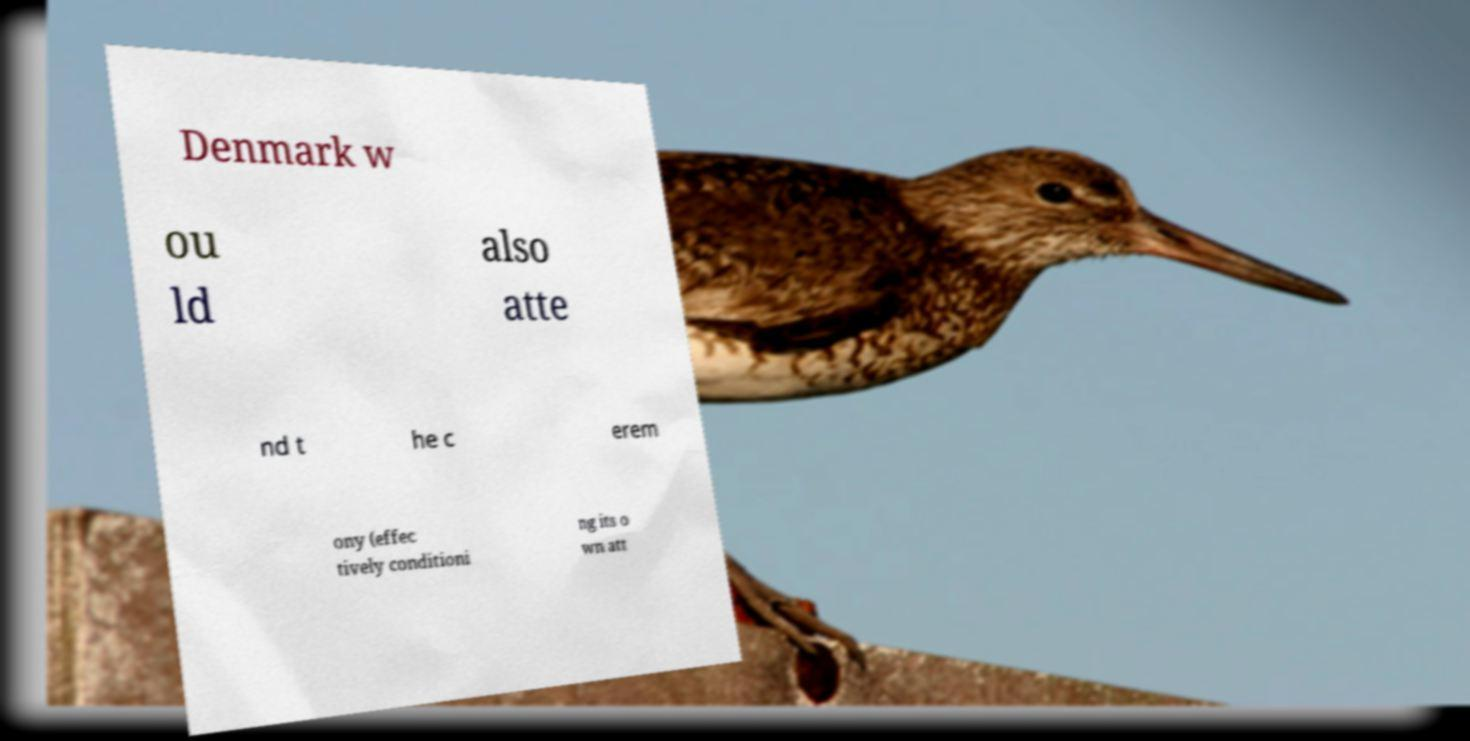Could you extract and type out the text from this image? Denmark w ou ld also atte nd t he c erem ony (effec tively conditioni ng its o wn att 